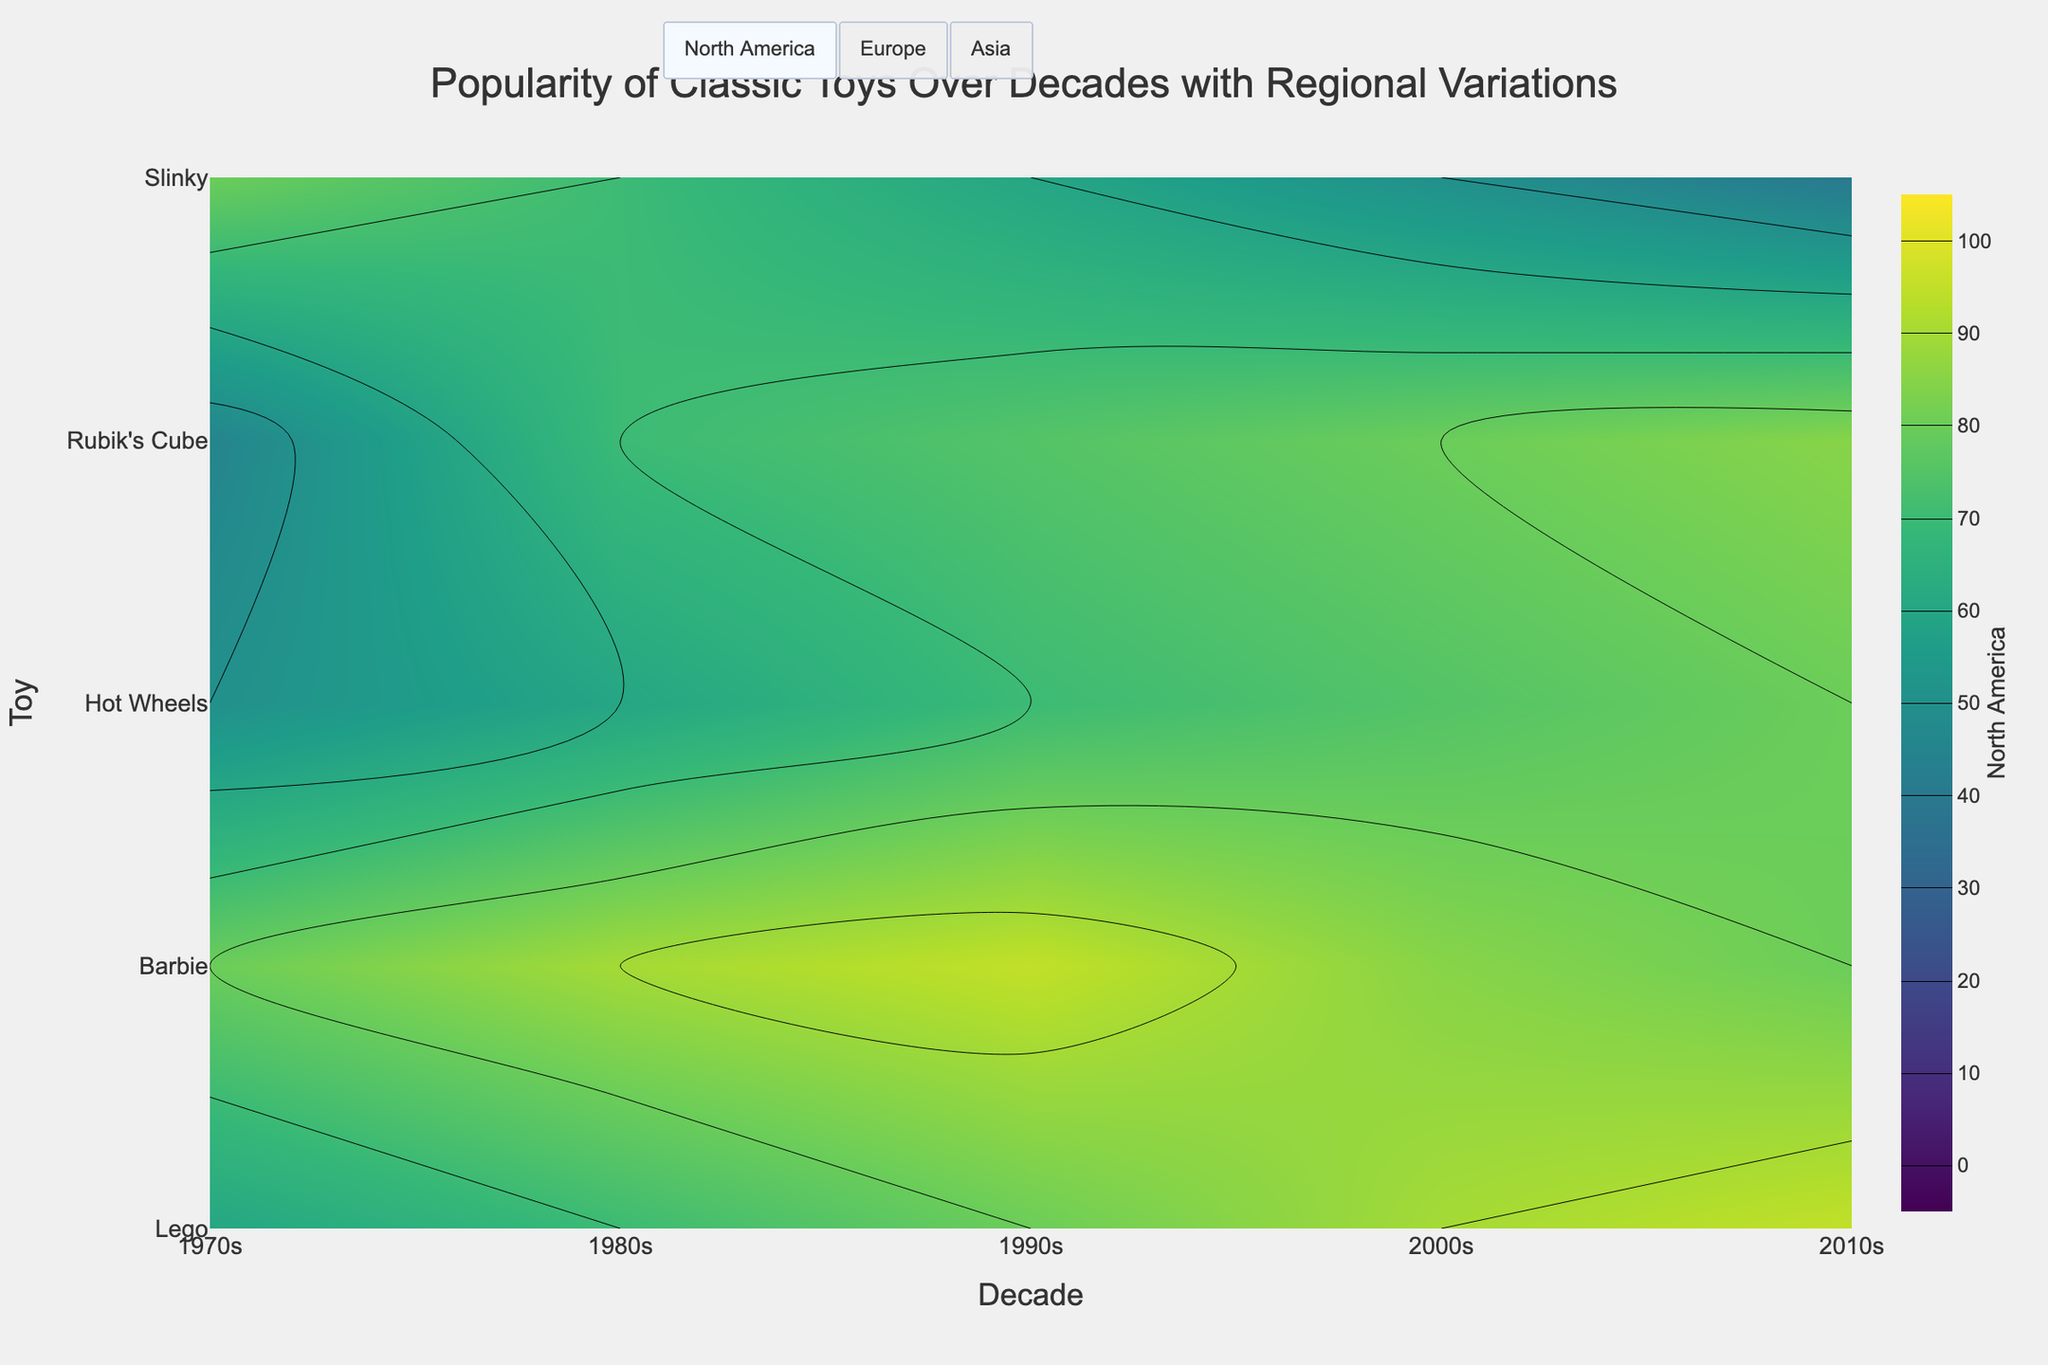What is the title of the plot? The title is displayed at the top of the figure. It provides a summary of what the figure is about. The title of this plot is "Popularity of Classic Toys Over Decades with Regional Variations."
Answer: Popularity of Classic Toys Over Decades with Regional Variations How does the popularity of Lego in North America change from the 1970s to the 2010s? Observe the contour plot for North America, locate the Lego toy on the y-axis, and follow the trend from the 1970s to the 2010s on the x-axis. The value starts at 60 and increases to 95.
Answer: It increases from 60 to 95 Which toy had the highest popularity in Europe during the 1980s? Observe the contour plot for Europe and look at the values for each toy for the 1980s. Barbie has the highest popularity at 80.
Answer: Barbie How does the popularity trend of Slinky in Asia compare to North America over the decades? Track the changes for Slinky in both regions across the decades. The popularity in Asia starts from 50 in 1970s and decreases to 20 in 2010s. In North America, it starts at 80 and decreases to 40 by 2010s. Both regions show a decline but at different initial and final values.
Answer: Both decrease, but North America starts higher and ends higher What is the average popularity of Rubik's Cube across all three regions in the 1990s? Locate the popularity values for Rubik's Cube in the 1990s for North America, Europe, and Asia. Sum these values (75, 70, and 65) and divide by 3.
Answer: (75 + 70 + 65) / 3 = 70 Which toy shows the highest overall increase in popularity in Asia from the 1970s to the 2010s? Compare the increase in values from the 1970s to the 2010s for all toys in Asia. Rubik's Cube increases from 35 to 75, showing the highest increase by 40 points.
Answer: Rubik's Cube During which decade did Hot Wheels first become equally or more popular than Barbie in North America? Track the values for Hot Wheels and Barbie in North America across the decades. Hot Wheels catch up to Barbie in the 2010s, both having a value of 80.
Answer: 2010s What decade shows the sharpest increase in popularity for Lego in Europe? Examine the contour plot for Lego in Europe across the decades. The sharpest increase is between the 1970s (55) and 1980s (65), with a 10-point increase.
Answer: 1980s Is there a decade where Barbie is more popular in Asia than it is in North America? Compare the values of Barbie in North America and Asia for each decade. There is no decade where Barbie is more popular in Asia than in North America.
Answer: No 